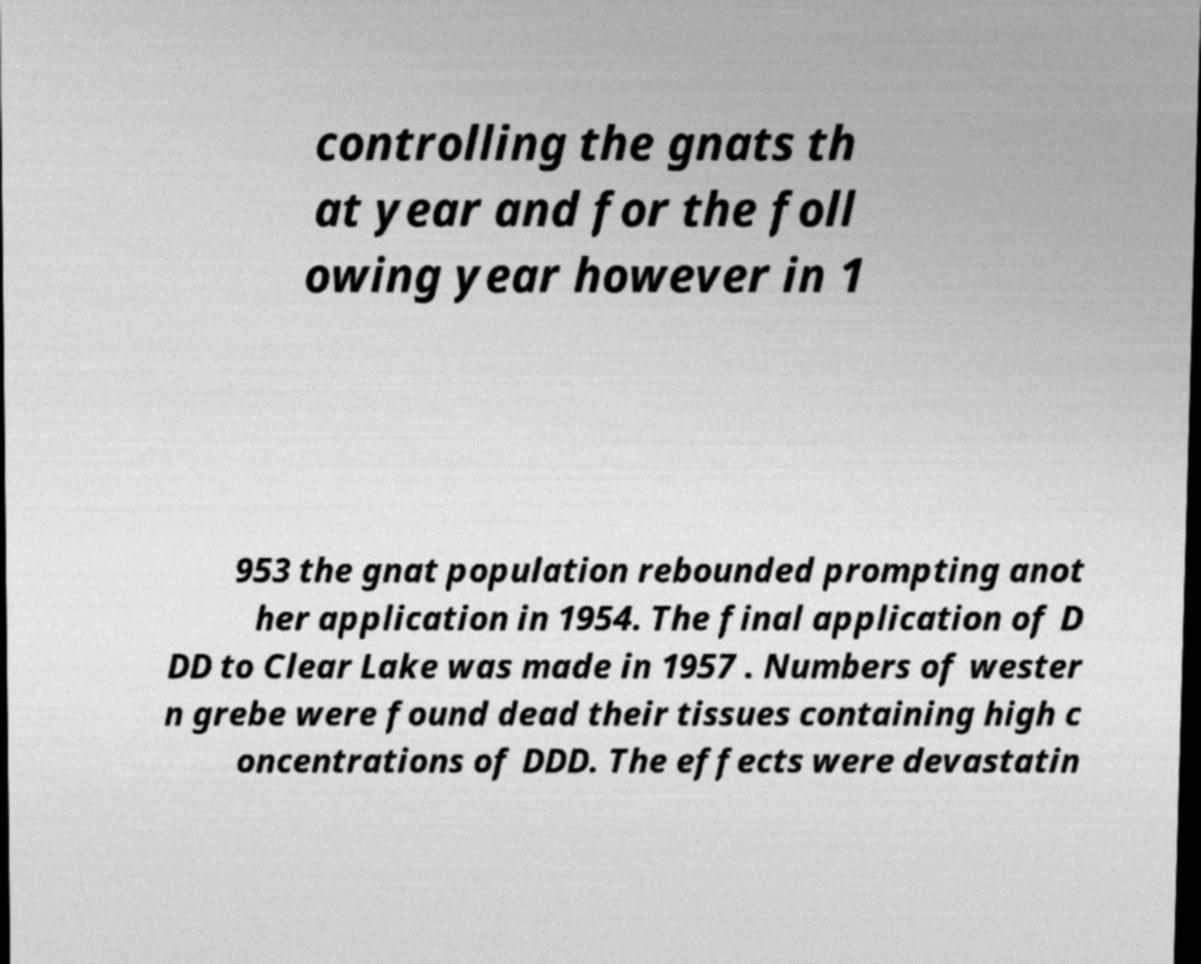I need the written content from this picture converted into text. Can you do that? controlling the gnats th at year and for the foll owing year however in 1 953 the gnat population rebounded prompting anot her application in 1954. The final application of D DD to Clear Lake was made in 1957 . Numbers of wester n grebe were found dead their tissues containing high c oncentrations of DDD. The effects were devastatin 